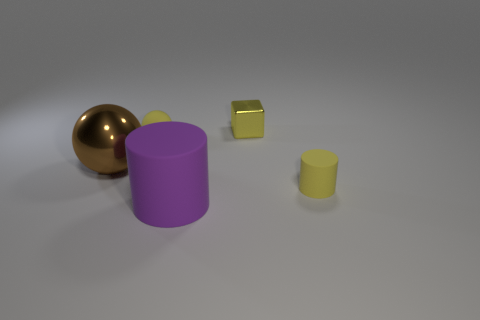Is the metal cube the same color as the tiny rubber ball?
Ensure brevity in your answer.  Yes. What material is the block that is the same color as the small rubber ball?
Your response must be concise. Metal. There is a thing that is both left of the purple cylinder and on the right side of the large brown metal ball; what is its color?
Give a very brief answer. Yellow. Are the cylinder that is in front of the yellow rubber cylinder and the tiny cylinder made of the same material?
Your answer should be very brief. Yes. Is the number of yellow things on the right side of the small yellow cylinder less than the number of large red cubes?
Your response must be concise. No. Are there any big purple cylinders made of the same material as the brown sphere?
Give a very brief answer. No. Do the brown ball and the yellow rubber object that is right of the purple rubber object have the same size?
Offer a terse response. No. Are there any rubber objects of the same color as the large rubber cylinder?
Provide a short and direct response. No. Is the material of the tiny yellow cube the same as the yellow cylinder?
Your answer should be very brief. No. There is a large brown shiny ball; how many yellow metallic objects are to the right of it?
Provide a succinct answer. 1. 